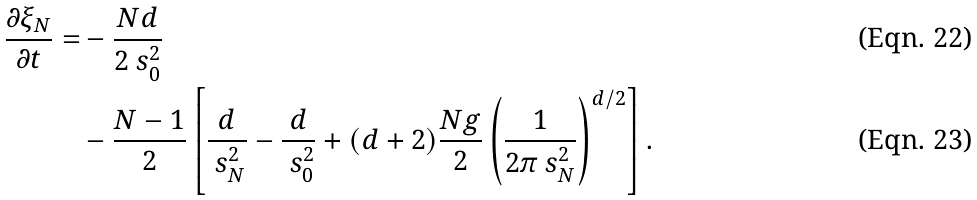<formula> <loc_0><loc_0><loc_500><loc_500>\frac { \partial \xi _ { N } } { \partial t } = & - \frac { N d } { 2 \ s _ { 0 } ^ { 2 } } \\ & - \frac { N - 1 } { 2 } \left [ \frac { d } { \ s _ { N } ^ { 2 } } - \frac { d } { \ s _ { 0 } ^ { 2 } } + ( d + 2 ) \frac { N g } { 2 } \left ( \frac { 1 } { 2 \pi \ s _ { N } ^ { 2 } } \right ) ^ { d / 2 } \right ] .</formula> 